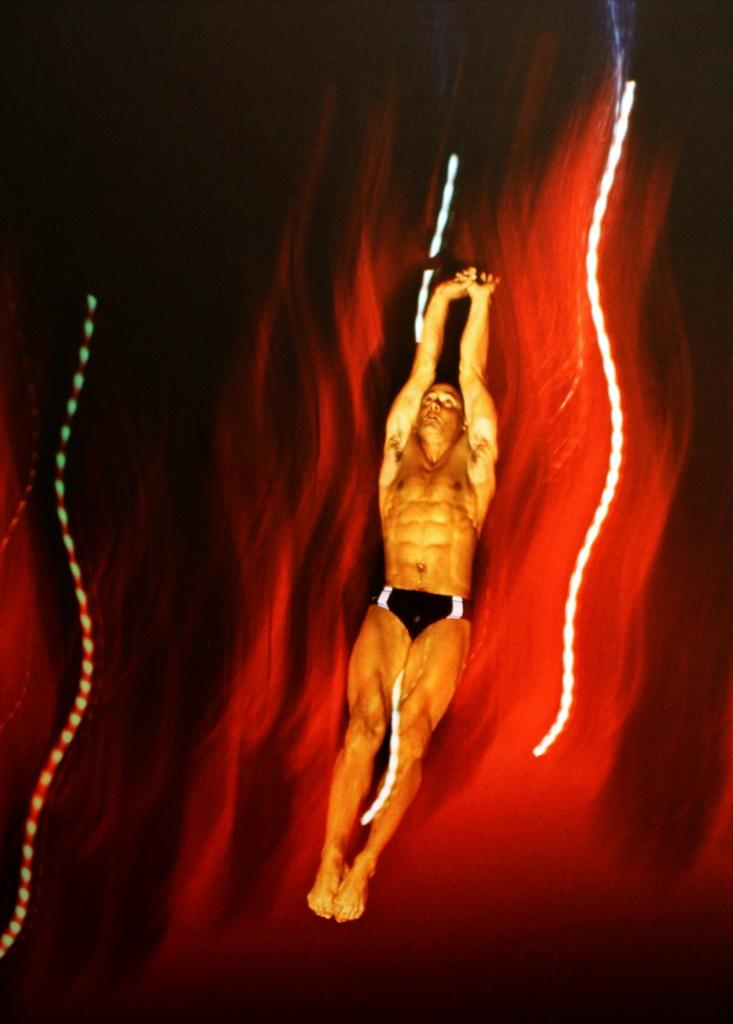What color is the background of the image? The background of the image is red. What objects can be seen on the sides of the image? There are two ropes on the left and right sides of the image. What is the man in the image doing? A man is holding a rope with his hands in the middle of the image. How many desks are visible in the image? There are no desks present in the image. What type of houses can be seen in the background of the image? There are no houses visible in the image; the background is red. 